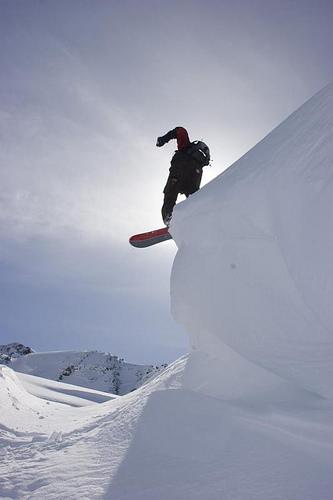What is on the ground?
Short answer required. Snow. Would this be a good place to wear a sundress and sandals?
Concise answer only. No. Is this person going to land softly?
Write a very short answer. No. 